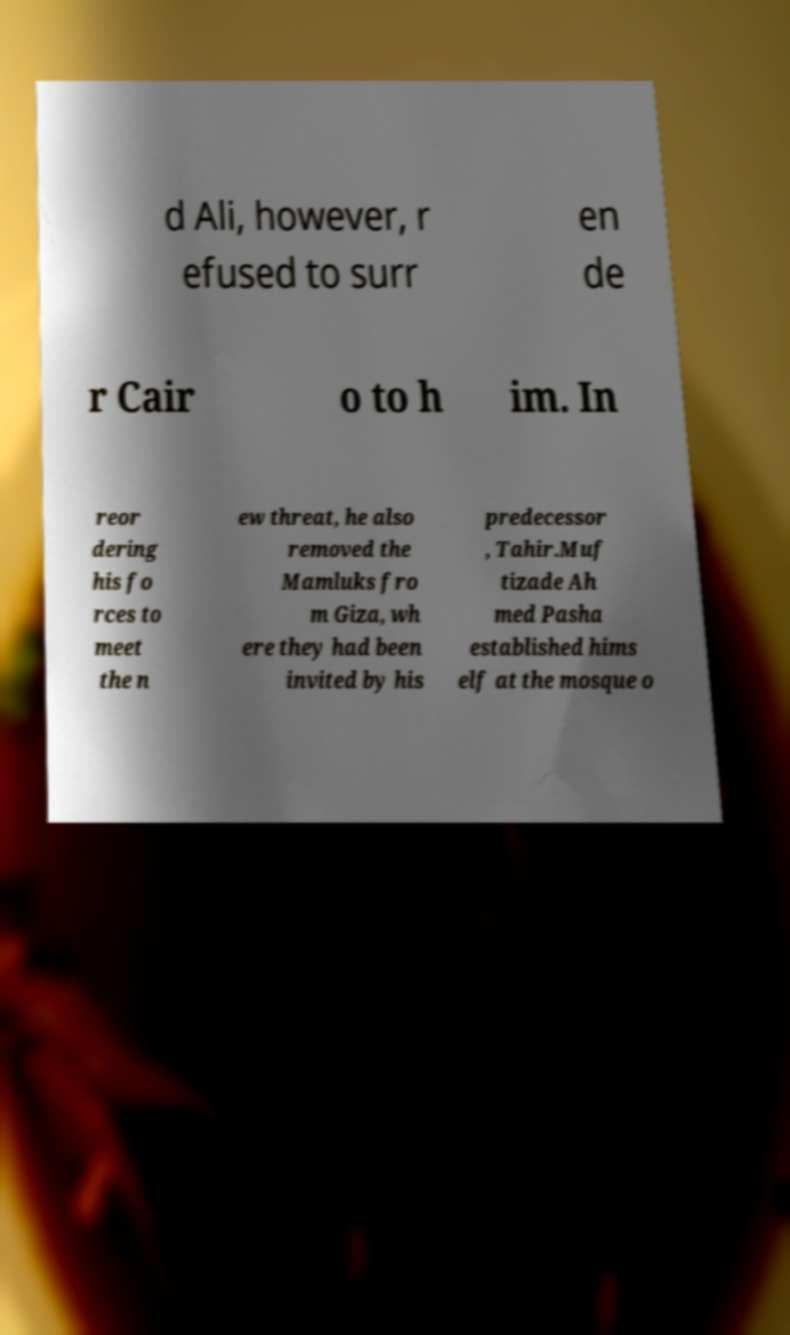There's text embedded in this image that I need extracted. Can you transcribe it verbatim? d Ali, however, r efused to surr en de r Cair o to h im. In reor dering his fo rces to meet the n ew threat, he also removed the Mamluks fro m Giza, wh ere they had been invited by his predecessor , Tahir.Muf tizade Ah med Pasha established hims elf at the mosque o 